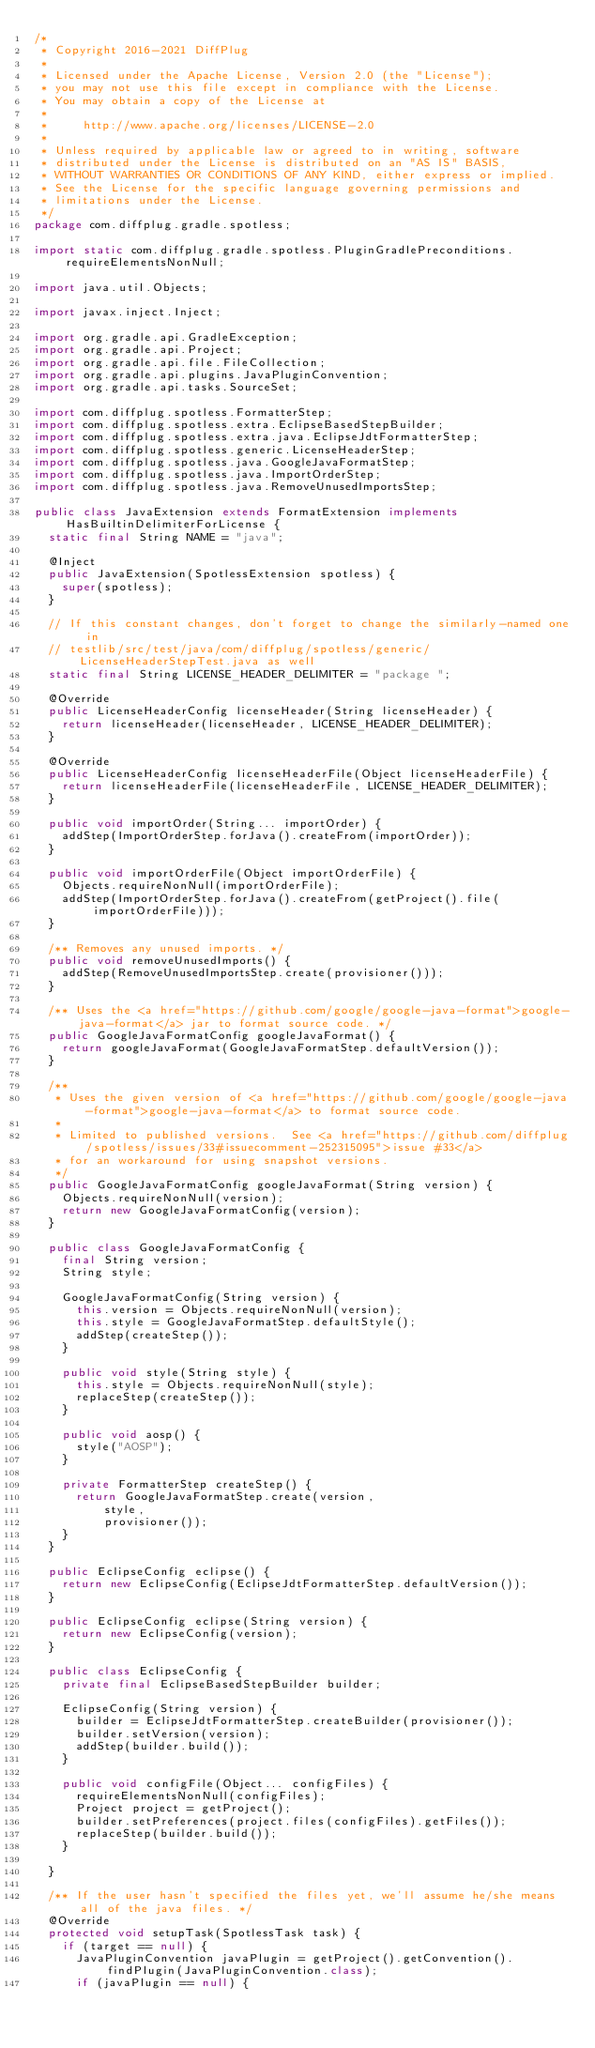<code> <loc_0><loc_0><loc_500><loc_500><_Java_>/*
 * Copyright 2016-2021 DiffPlug
 *
 * Licensed under the Apache License, Version 2.0 (the "License");
 * you may not use this file except in compliance with the License.
 * You may obtain a copy of the License at
 *
 *     http://www.apache.org/licenses/LICENSE-2.0
 *
 * Unless required by applicable law or agreed to in writing, software
 * distributed under the License is distributed on an "AS IS" BASIS,
 * WITHOUT WARRANTIES OR CONDITIONS OF ANY KIND, either express or implied.
 * See the License for the specific language governing permissions and
 * limitations under the License.
 */
package com.diffplug.gradle.spotless;

import static com.diffplug.gradle.spotless.PluginGradlePreconditions.requireElementsNonNull;

import java.util.Objects;

import javax.inject.Inject;

import org.gradle.api.GradleException;
import org.gradle.api.Project;
import org.gradle.api.file.FileCollection;
import org.gradle.api.plugins.JavaPluginConvention;
import org.gradle.api.tasks.SourceSet;

import com.diffplug.spotless.FormatterStep;
import com.diffplug.spotless.extra.EclipseBasedStepBuilder;
import com.diffplug.spotless.extra.java.EclipseJdtFormatterStep;
import com.diffplug.spotless.generic.LicenseHeaderStep;
import com.diffplug.spotless.java.GoogleJavaFormatStep;
import com.diffplug.spotless.java.ImportOrderStep;
import com.diffplug.spotless.java.RemoveUnusedImportsStep;

public class JavaExtension extends FormatExtension implements HasBuiltinDelimiterForLicense {
	static final String NAME = "java";

	@Inject
	public JavaExtension(SpotlessExtension spotless) {
		super(spotless);
	}

	// If this constant changes, don't forget to change the similarly-named one in
	// testlib/src/test/java/com/diffplug/spotless/generic/LicenseHeaderStepTest.java as well
	static final String LICENSE_HEADER_DELIMITER = "package ";

	@Override
	public LicenseHeaderConfig licenseHeader(String licenseHeader) {
		return licenseHeader(licenseHeader, LICENSE_HEADER_DELIMITER);
	}

	@Override
	public LicenseHeaderConfig licenseHeaderFile(Object licenseHeaderFile) {
		return licenseHeaderFile(licenseHeaderFile, LICENSE_HEADER_DELIMITER);
	}

	public void importOrder(String... importOrder) {
		addStep(ImportOrderStep.forJava().createFrom(importOrder));
	}

	public void importOrderFile(Object importOrderFile) {
		Objects.requireNonNull(importOrderFile);
		addStep(ImportOrderStep.forJava().createFrom(getProject().file(importOrderFile)));
	}

	/** Removes any unused imports. */
	public void removeUnusedImports() {
		addStep(RemoveUnusedImportsStep.create(provisioner()));
	}

	/** Uses the <a href="https://github.com/google/google-java-format">google-java-format</a> jar to format source code. */
	public GoogleJavaFormatConfig googleJavaFormat() {
		return googleJavaFormat(GoogleJavaFormatStep.defaultVersion());
	}

	/**
	 * Uses the given version of <a href="https://github.com/google/google-java-format">google-java-format</a> to format source code.
	 *
	 * Limited to published versions.  See <a href="https://github.com/diffplug/spotless/issues/33#issuecomment-252315095">issue #33</a>
	 * for an workaround for using snapshot versions.
	 */
	public GoogleJavaFormatConfig googleJavaFormat(String version) {
		Objects.requireNonNull(version);
		return new GoogleJavaFormatConfig(version);
	}

	public class GoogleJavaFormatConfig {
		final String version;
		String style;

		GoogleJavaFormatConfig(String version) {
			this.version = Objects.requireNonNull(version);
			this.style = GoogleJavaFormatStep.defaultStyle();
			addStep(createStep());
		}

		public void style(String style) {
			this.style = Objects.requireNonNull(style);
			replaceStep(createStep());
		}

		public void aosp() {
			style("AOSP");
		}

		private FormatterStep createStep() {
			return GoogleJavaFormatStep.create(version,
					style,
					provisioner());
		}
	}

	public EclipseConfig eclipse() {
		return new EclipseConfig(EclipseJdtFormatterStep.defaultVersion());
	}

	public EclipseConfig eclipse(String version) {
		return new EclipseConfig(version);
	}

	public class EclipseConfig {
		private final EclipseBasedStepBuilder builder;

		EclipseConfig(String version) {
			builder = EclipseJdtFormatterStep.createBuilder(provisioner());
			builder.setVersion(version);
			addStep(builder.build());
		}

		public void configFile(Object... configFiles) {
			requireElementsNonNull(configFiles);
			Project project = getProject();
			builder.setPreferences(project.files(configFiles).getFiles());
			replaceStep(builder.build());
		}

	}

	/** If the user hasn't specified the files yet, we'll assume he/she means all of the java files. */
	@Override
	protected void setupTask(SpotlessTask task) {
		if (target == null) {
			JavaPluginConvention javaPlugin = getProject().getConvention().findPlugin(JavaPluginConvention.class);
			if (javaPlugin == null) {</code> 